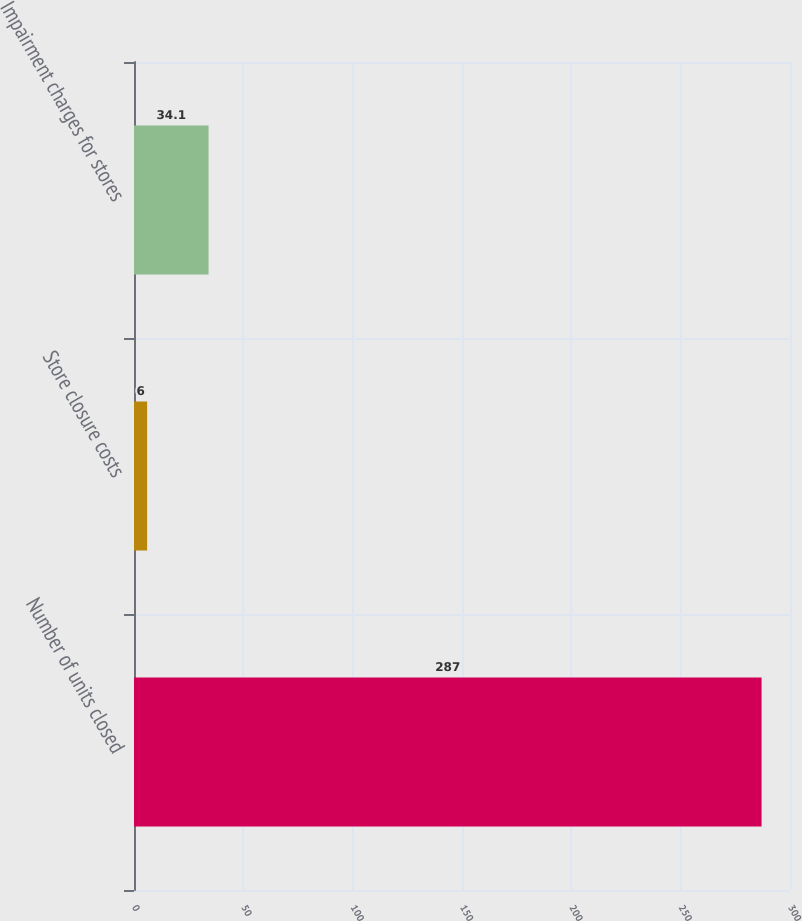<chart> <loc_0><loc_0><loc_500><loc_500><bar_chart><fcel>Number of units closed<fcel>Store closure costs<fcel>Impairment charges for stores<nl><fcel>287<fcel>6<fcel>34.1<nl></chart> 